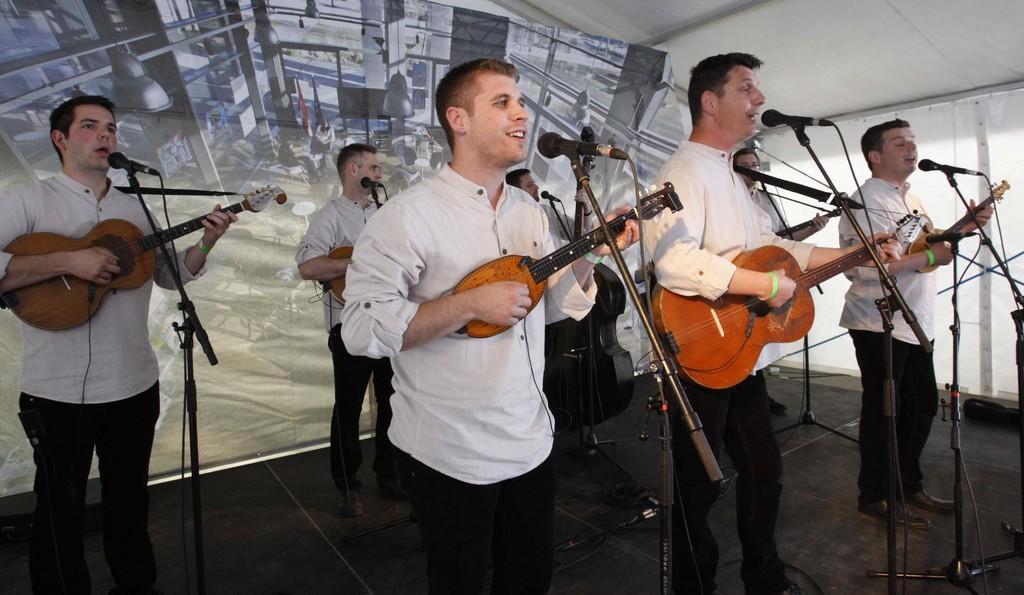In one or two sentences, can you explain what this image depicts? A group of people standing and holding the guitars, singing a song in the microphones. 